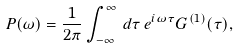Convert formula to latex. <formula><loc_0><loc_0><loc_500><loc_500>P ( \omega ) = \frac { 1 } { 2 \pi } \int _ { - \infty } ^ { \infty } \, d \tau \, e ^ { i \omega \tau } G ^ { ( 1 ) } ( \tau ) ,</formula> 